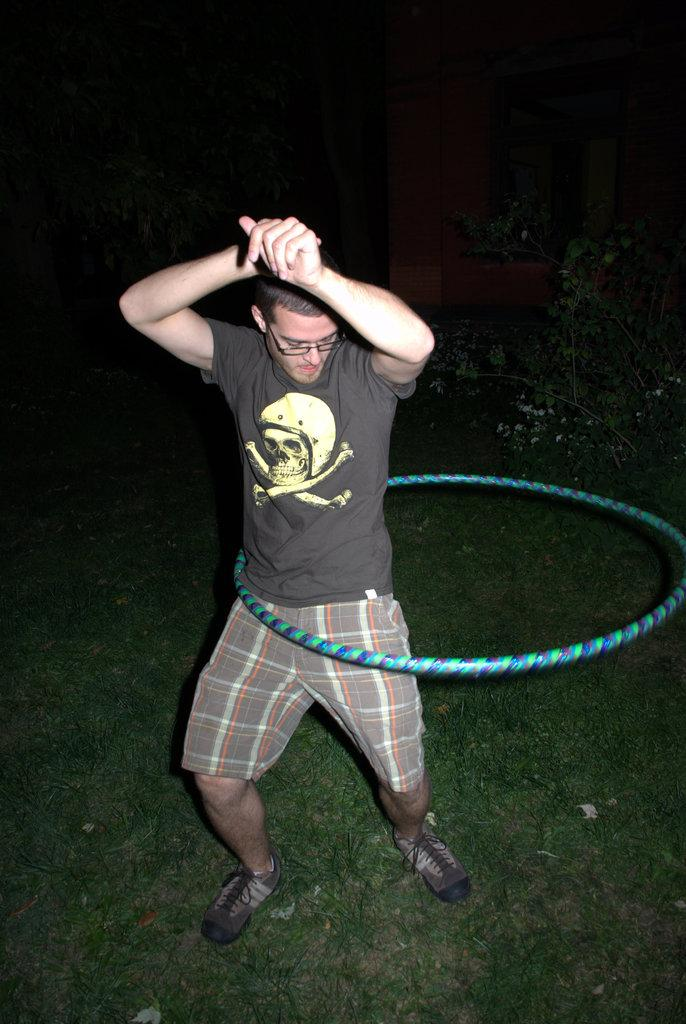What is the main subject of the image? The main subject of the image is a man standing on the ground. What is the man doing in the image? The man is standing with a hula hoop around his waist. What type of surface is the man standing on? The man is standing on grass. What can be seen in the background of the image? The background behind the man is dark. How far is the edge of the needle from the man in the image? There is no needle present in the image, so it is not possible to determine the distance from the man to the edge of a needle. 